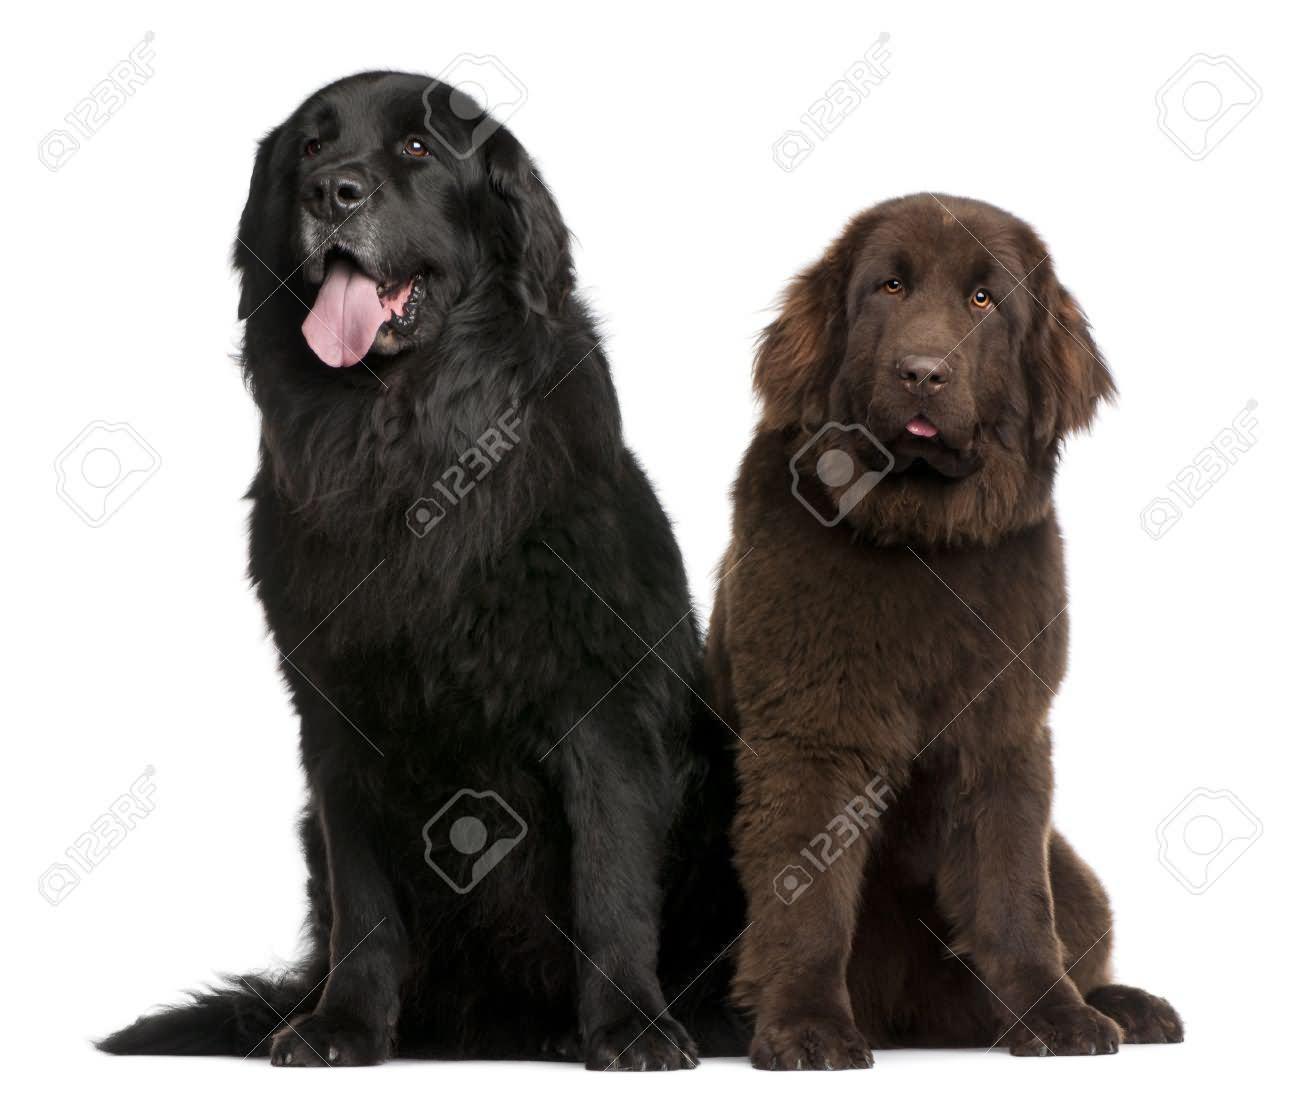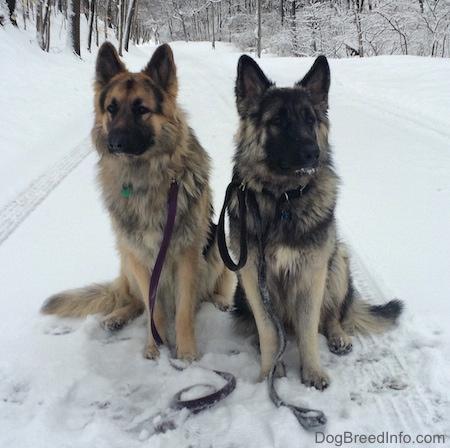The first image is the image on the left, the second image is the image on the right. Assess this claim about the two images: "In at least one of the images, two dog from the same breed are sitting next to each other.". Correct or not? Answer yes or no. Yes. The first image is the image on the left, the second image is the image on the right. Assess this claim about the two images: "The image on the right shows two dogs sitting next to each other outside.". Correct or not? Answer yes or no. Yes. 